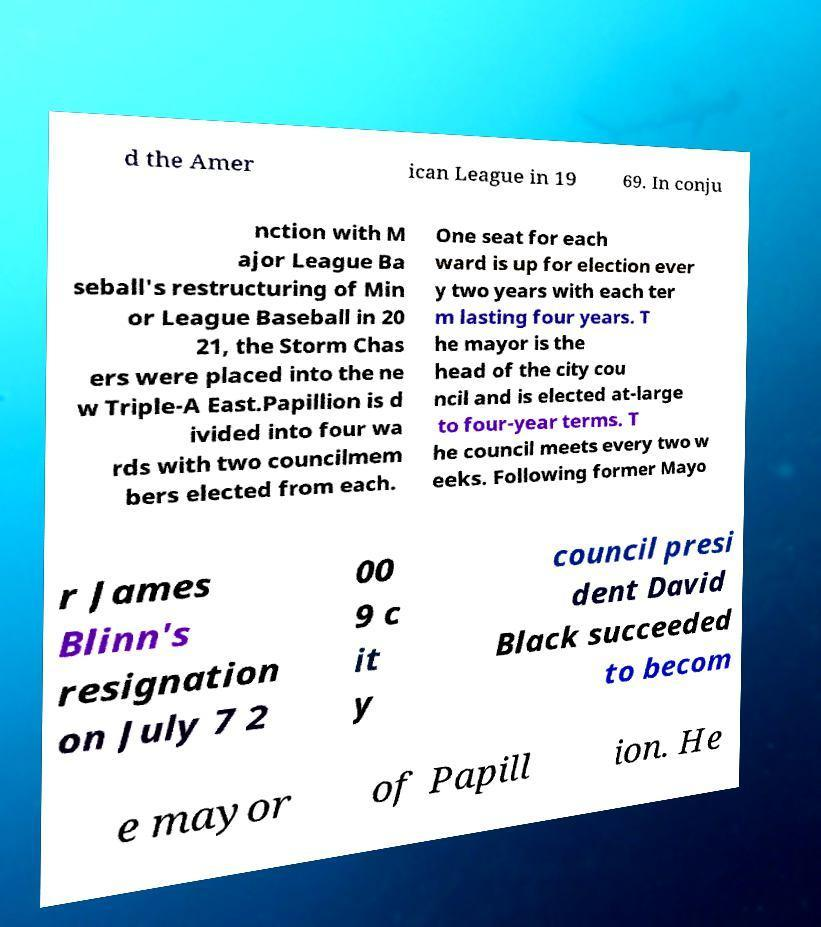Could you extract and type out the text from this image? d the Amer ican League in 19 69. In conju nction with M ajor League Ba seball's restructuring of Min or League Baseball in 20 21, the Storm Chas ers were placed into the ne w Triple-A East.Papillion is d ivided into four wa rds with two councilmem bers elected from each. One seat for each ward is up for election ever y two years with each ter m lasting four years. T he mayor is the head of the city cou ncil and is elected at-large to four-year terms. T he council meets every two w eeks. Following former Mayo r James Blinn's resignation on July 7 2 00 9 c it y council presi dent David Black succeeded to becom e mayor of Papill ion. He 